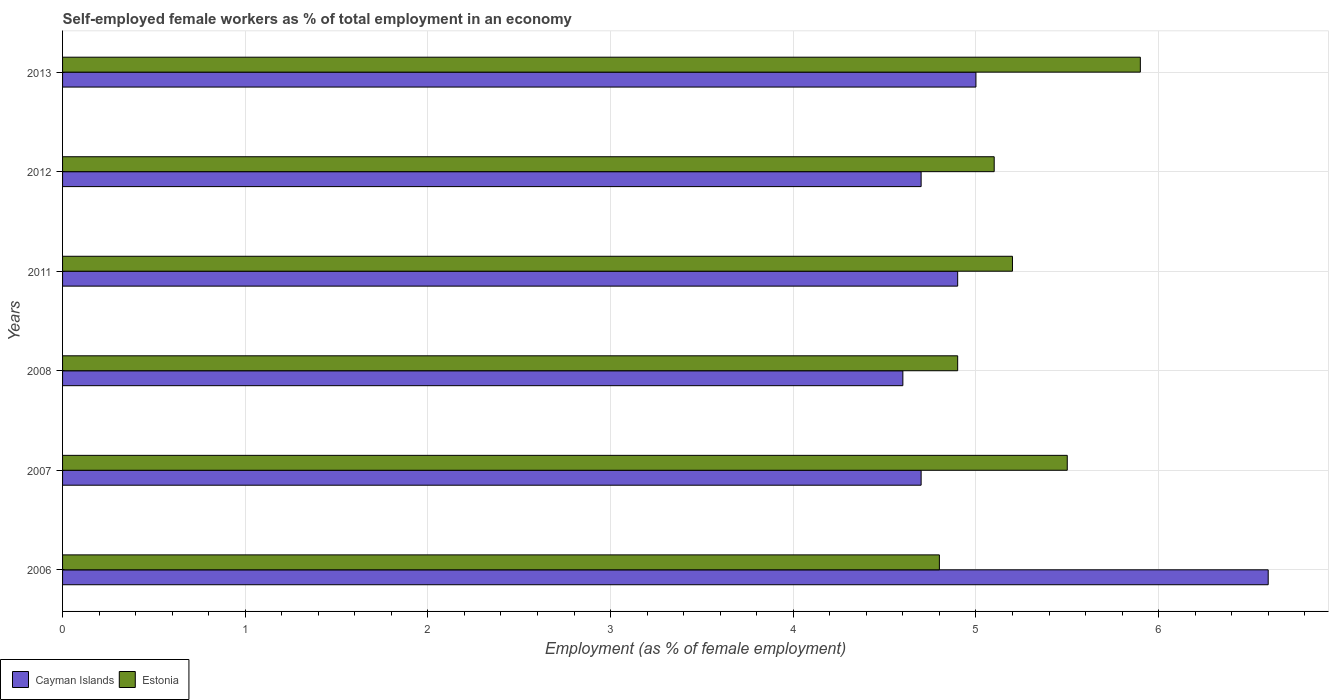How many different coloured bars are there?
Your response must be concise. 2. How many groups of bars are there?
Ensure brevity in your answer.  6. How many bars are there on the 5th tick from the bottom?
Offer a very short reply. 2. What is the percentage of self-employed female workers in Estonia in 2008?
Your answer should be very brief. 4.9. Across all years, what is the maximum percentage of self-employed female workers in Estonia?
Ensure brevity in your answer.  5.9. Across all years, what is the minimum percentage of self-employed female workers in Cayman Islands?
Your response must be concise. 4.6. What is the total percentage of self-employed female workers in Cayman Islands in the graph?
Ensure brevity in your answer.  30.5. What is the difference between the percentage of self-employed female workers in Estonia in 2008 and that in 2012?
Your answer should be very brief. -0.2. What is the difference between the percentage of self-employed female workers in Cayman Islands in 2008 and the percentage of self-employed female workers in Estonia in 2013?
Provide a short and direct response. -1.3. What is the average percentage of self-employed female workers in Cayman Islands per year?
Give a very brief answer. 5.08. In the year 2007, what is the difference between the percentage of self-employed female workers in Cayman Islands and percentage of self-employed female workers in Estonia?
Provide a succinct answer. -0.8. What is the ratio of the percentage of self-employed female workers in Estonia in 2011 to that in 2013?
Your answer should be compact. 0.88. Is the percentage of self-employed female workers in Estonia in 2006 less than that in 2012?
Your answer should be compact. Yes. What is the difference between the highest and the second highest percentage of self-employed female workers in Estonia?
Provide a succinct answer. 0.4. What is the difference between the highest and the lowest percentage of self-employed female workers in Cayman Islands?
Offer a very short reply. 2. In how many years, is the percentage of self-employed female workers in Cayman Islands greater than the average percentage of self-employed female workers in Cayman Islands taken over all years?
Offer a terse response. 1. Is the sum of the percentage of self-employed female workers in Estonia in 2007 and 2012 greater than the maximum percentage of self-employed female workers in Cayman Islands across all years?
Your response must be concise. Yes. What does the 1st bar from the top in 2008 represents?
Make the answer very short. Estonia. What does the 2nd bar from the bottom in 2007 represents?
Ensure brevity in your answer.  Estonia. How many bars are there?
Keep it short and to the point. 12. Does the graph contain grids?
Offer a terse response. Yes. Where does the legend appear in the graph?
Keep it short and to the point. Bottom left. What is the title of the graph?
Provide a succinct answer. Self-employed female workers as % of total employment in an economy. What is the label or title of the X-axis?
Ensure brevity in your answer.  Employment (as % of female employment). What is the Employment (as % of female employment) of Cayman Islands in 2006?
Your answer should be very brief. 6.6. What is the Employment (as % of female employment) in Estonia in 2006?
Provide a succinct answer. 4.8. What is the Employment (as % of female employment) of Cayman Islands in 2007?
Offer a terse response. 4.7. What is the Employment (as % of female employment) in Estonia in 2007?
Give a very brief answer. 5.5. What is the Employment (as % of female employment) in Cayman Islands in 2008?
Offer a very short reply. 4.6. What is the Employment (as % of female employment) of Estonia in 2008?
Ensure brevity in your answer.  4.9. What is the Employment (as % of female employment) of Cayman Islands in 2011?
Your response must be concise. 4.9. What is the Employment (as % of female employment) of Estonia in 2011?
Provide a succinct answer. 5.2. What is the Employment (as % of female employment) of Cayman Islands in 2012?
Make the answer very short. 4.7. What is the Employment (as % of female employment) in Estonia in 2012?
Make the answer very short. 5.1. What is the Employment (as % of female employment) in Estonia in 2013?
Provide a short and direct response. 5.9. Across all years, what is the maximum Employment (as % of female employment) of Cayman Islands?
Your answer should be compact. 6.6. Across all years, what is the maximum Employment (as % of female employment) in Estonia?
Offer a terse response. 5.9. Across all years, what is the minimum Employment (as % of female employment) in Cayman Islands?
Your answer should be compact. 4.6. Across all years, what is the minimum Employment (as % of female employment) in Estonia?
Keep it short and to the point. 4.8. What is the total Employment (as % of female employment) in Cayman Islands in the graph?
Offer a terse response. 30.5. What is the total Employment (as % of female employment) of Estonia in the graph?
Offer a terse response. 31.4. What is the difference between the Employment (as % of female employment) of Cayman Islands in 2006 and that in 2008?
Ensure brevity in your answer.  2. What is the difference between the Employment (as % of female employment) in Cayman Islands in 2006 and that in 2011?
Provide a succinct answer. 1.7. What is the difference between the Employment (as % of female employment) of Estonia in 2006 and that in 2012?
Offer a very short reply. -0.3. What is the difference between the Employment (as % of female employment) in Estonia in 2006 and that in 2013?
Keep it short and to the point. -1.1. What is the difference between the Employment (as % of female employment) in Cayman Islands in 2007 and that in 2008?
Provide a short and direct response. 0.1. What is the difference between the Employment (as % of female employment) of Estonia in 2007 and that in 2011?
Provide a short and direct response. 0.3. What is the difference between the Employment (as % of female employment) of Estonia in 2007 and that in 2012?
Keep it short and to the point. 0.4. What is the difference between the Employment (as % of female employment) of Cayman Islands in 2007 and that in 2013?
Offer a terse response. -0.3. What is the difference between the Employment (as % of female employment) in Estonia in 2008 and that in 2011?
Provide a succinct answer. -0.3. What is the difference between the Employment (as % of female employment) in Cayman Islands in 2008 and that in 2012?
Make the answer very short. -0.1. What is the difference between the Employment (as % of female employment) of Estonia in 2008 and that in 2012?
Your answer should be very brief. -0.2. What is the difference between the Employment (as % of female employment) of Estonia in 2008 and that in 2013?
Make the answer very short. -1. What is the difference between the Employment (as % of female employment) in Cayman Islands in 2011 and that in 2013?
Your answer should be compact. -0.1. What is the difference between the Employment (as % of female employment) in Estonia in 2012 and that in 2013?
Your answer should be very brief. -0.8. What is the difference between the Employment (as % of female employment) of Cayman Islands in 2006 and the Employment (as % of female employment) of Estonia in 2008?
Provide a short and direct response. 1.7. What is the difference between the Employment (as % of female employment) of Cayman Islands in 2007 and the Employment (as % of female employment) of Estonia in 2011?
Offer a very short reply. -0.5. What is the difference between the Employment (as % of female employment) of Cayman Islands in 2008 and the Employment (as % of female employment) of Estonia in 2013?
Give a very brief answer. -1.3. What is the difference between the Employment (as % of female employment) in Cayman Islands in 2011 and the Employment (as % of female employment) in Estonia in 2012?
Make the answer very short. -0.2. What is the difference between the Employment (as % of female employment) in Cayman Islands in 2012 and the Employment (as % of female employment) in Estonia in 2013?
Your response must be concise. -1.2. What is the average Employment (as % of female employment) in Cayman Islands per year?
Your answer should be very brief. 5.08. What is the average Employment (as % of female employment) of Estonia per year?
Your answer should be very brief. 5.23. In the year 2007, what is the difference between the Employment (as % of female employment) in Cayman Islands and Employment (as % of female employment) in Estonia?
Offer a very short reply. -0.8. In the year 2013, what is the difference between the Employment (as % of female employment) in Cayman Islands and Employment (as % of female employment) in Estonia?
Keep it short and to the point. -0.9. What is the ratio of the Employment (as % of female employment) in Cayman Islands in 2006 to that in 2007?
Your answer should be compact. 1.4. What is the ratio of the Employment (as % of female employment) of Estonia in 2006 to that in 2007?
Provide a short and direct response. 0.87. What is the ratio of the Employment (as % of female employment) of Cayman Islands in 2006 to that in 2008?
Ensure brevity in your answer.  1.43. What is the ratio of the Employment (as % of female employment) in Estonia in 2006 to that in 2008?
Ensure brevity in your answer.  0.98. What is the ratio of the Employment (as % of female employment) in Cayman Islands in 2006 to that in 2011?
Provide a succinct answer. 1.35. What is the ratio of the Employment (as % of female employment) of Cayman Islands in 2006 to that in 2012?
Your answer should be very brief. 1.4. What is the ratio of the Employment (as % of female employment) in Cayman Islands in 2006 to that in 2013?
Provide a short and direct response. 1.32. What is the ratio of the Employment (as % of female employment) in Estonia in 2006 to that in 2013?
Provide a short and direct response. 0.81. What is the ratio of the Employment (as % of female employment) of Cayman Islands in 2007 to that in 2008?
Provide a short and direct response. 1.02. What is the ratio of the Employment (as % of female employment) of Estonia in 2007 to that in 2008?
Make the answer very short. 1.12. What is the ratio of the Employment (as % of female employment) of Cayman Islands in 2007 to that in 2011?
Make the answer very short. 0.96. What is the ratio of the Employment (as % of female employment) in Estonia in 2007 to that in 2011?
Your answer should be compact. 1.06. What is the ratio of the Employment (as % of female employment) of Cayman Islands in 2007 to that in 2012?
Offer a terse response. 1. What is the ratio of the Employment (as % of female employment) in Estonia in 2007 to that in 2012?
Make the answer very short. 1.08. What is the ratio of the Employment (as % of female employment) of Cayman Islands in 2007 to that in 2013?
Your answer should be compact. 0.94. What is the ratio of the Employment (as % of female employment) of Estonia in 2007 to that in 2013?
Keep it short and to the point. 0.93. What is the ratio of the Employment (as % of female employment) of Cayman Islands in 2008 to that in 2011?
Offer a terse response. 0.94. What is the ratio of the Employment (as % of female employment) in Estonia in 2008 to that in 2011?
Make the answer very short. 0.94. What is the ratio of the Employment (as % of female employment) of Cayman Islands in 2008 to that in 2012?
Your answer should be compact. 0.98. What is the ratio of the Employment (as % of female employment) of Estonia in 2008 to that in 2012?
Provide a succinct answer. 0.96. What is the ratio of the Employment (as % of female employment) in Cayman Islands in 2008 to that in 2013?
Ensure brevity in your answer.  0.92. What is the ratio of the Employment (as % of female employment) in Estonia in 2008 to that in 2013?
Offer a terse response. 0.83. What is the ratio of the Employment (as % of female employment) of Cayman Islands in 2011 to that in 2012?
Provide a succinct answer. 1.04. What is the ratio of the Employment (as % of female employment) in Estonia in 2011 to that in 2012?
Offer a terse response. 1.02. What is the ratio of the Employment (as % of female employment) of Cayman Islands in 2011 to that in 2013?
Keep it short and to the point. 0.98. What is the ratio of the Employment (as % of female employment) of Estonia in 2011 to that in 2013?
Keep it short and to the point. 0.88. What is the ratio of the Employment (as % of female employment) in Estonia in 2012 to that in 2013?
Offer a very short reply. 0.86. What is the difference between the highest and the second highest Employment (as % of female employment) in Cayman Islands?
Provide a succinct answer. 1.6. What is the difference between the highest and the lowest Employment (as % of female employment) in Cayman Islands?
Your answer should be very brief. 2. What is the difference between the highest and the lowest Employment (as % of female employment) of Estonia?
Your answer should be compact. 1.1. 